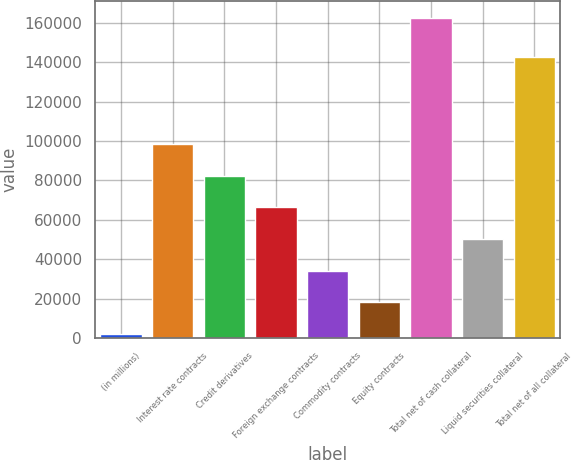Convert chart to OTSL. <chart><loc_0><loc_0><loc_500><loc_500><bar_chart><fcel>(in millions)<fcel>Interest rate contracts<fcel>Credit derivatives<fcel>Foreign exchange contracts<fcel>Commodity contracts<fcel>Equity contracts<fcel>Total net of cash collateral<fcel>Liquid securities collateral<fcel>Total net of all collateral<nl><fcel>2008<fcel>98378.8<fcel>82317<fcel>66255.2<fcel>34131.6<fcel>18069.8<fcel>162626<fcel>50193.4<fcel>142810<nl></chart> 